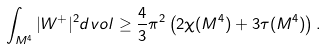<formula> <loc_0><loc_0><loc_500><loc_500>\int _ { M ^ { 4 } } | W ^ { + } | ^ { 2 } d v o l \geq \frac { 4 } { 3 } \pi ^ { 2 } \left ( 2 \chi ( M ^ { 4 } ) + 3 \tau ( M ^ { 4 } ) \right ) .</formula> 